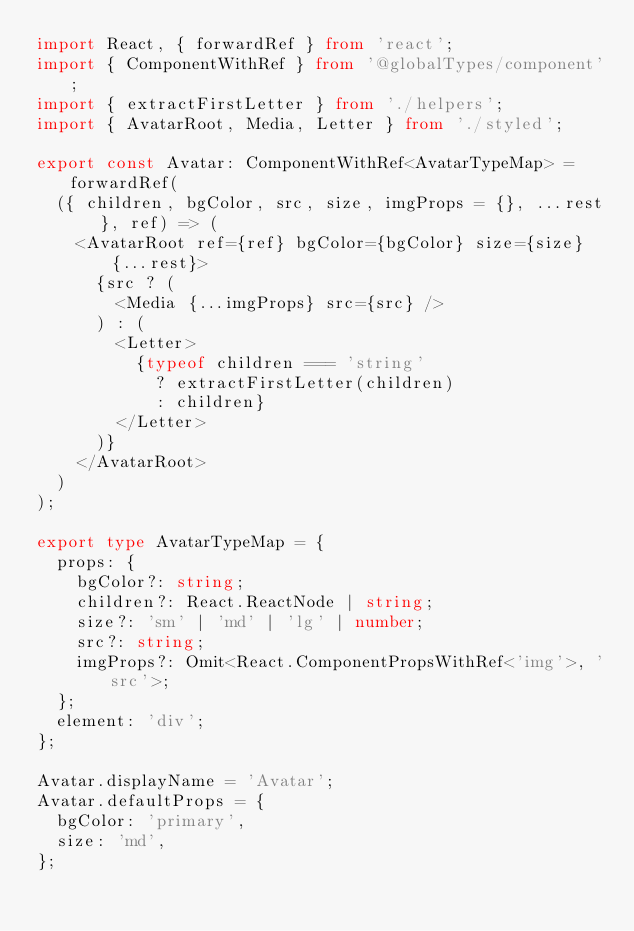Convert code to text. <code><loc_0><loc_0><loc_500><loc_500><_TypeScript_>import React, { forwardRef } from 'react';
import { ComponentWithRef } from '@globalTypes/component';
import { extractFirstLetter } from './helpers';
import { AvatarRoot, Media, Letter } from './styled';

export const Avatar: ComponentWithRef<AvatarTypeMap> = forwardRef(
  ({ children, bgColor, src, size, imgProps = {}, ...rest }, ref) => (
    <AvatarRoot ref={ref} bgColor={bgColor} size={size} {...rest}>
      {src ? (
        <Media {...imgProps} src={src} />
      ) : (
        <Letter>
          {typeof children === 'string'
            ? extractFirstLetter(children)
            : children}
        </Letter>
      )}
    </AvatarRoot>
  )
);

export type AvatarTypeMap = {
  props: {
    bgColor?: string;
    children?: React.ReactNode | string;
    size?: 'sm' | 'md' | 'lg' | number;
    src?: string;
    imgProps?: Omit<React.ComponentPropsWithRef<'img'>, 'src'>;
  };
  element: 'div';
};

Avatar.displayName = 'Avatar';
Avatar.defaultProps = {
  bgColor: 'primary',
  size: 'md',
};
</code> 